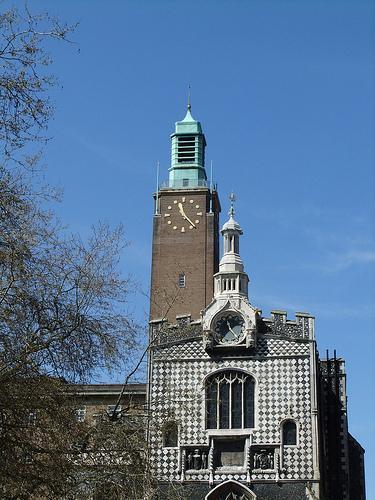How many clocks are shown?
Give a very brief answer. 2. 